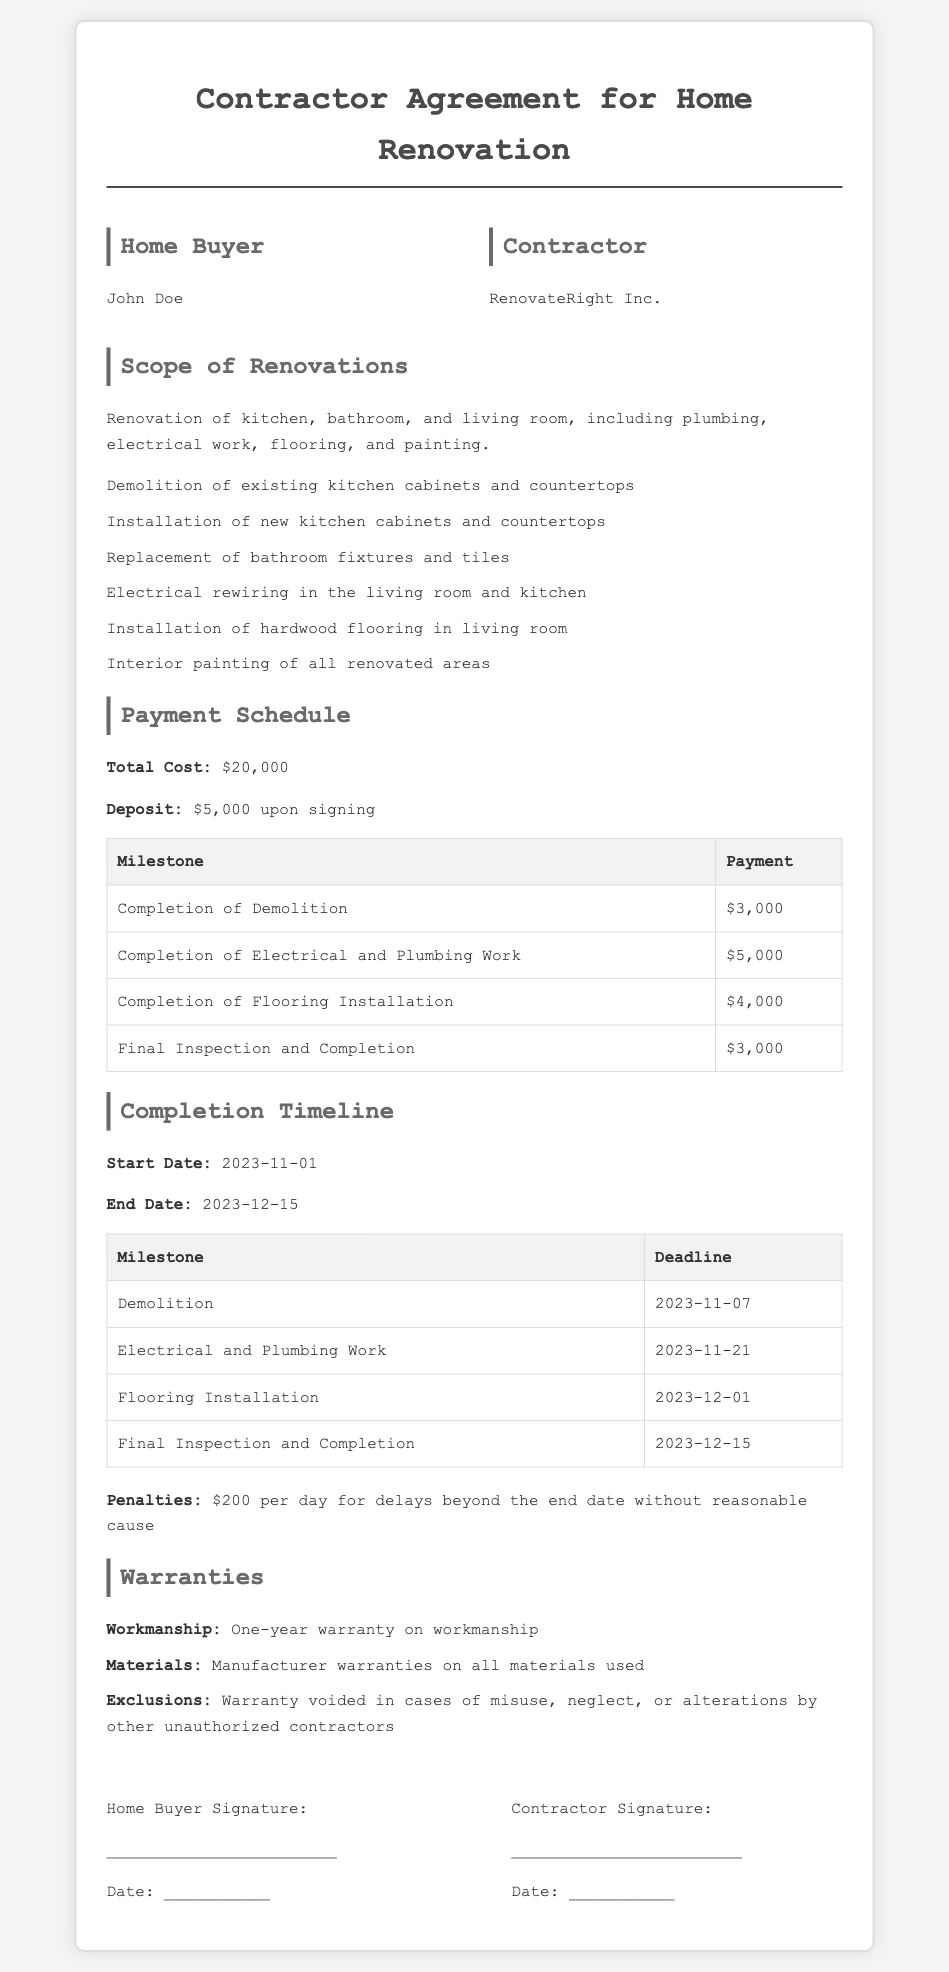what is the total cost of the renovation? The total cost is stated explicitly in the Payment Schedule section of the document.
Answer: $20,000 what is the deposit amount required upon signing? The deposit amount is specified in the Payment Schedule section.
Answer: $5,000 when is the start date of the renovation? The start date is outlined in the Completion Timeline section.
Answer: 2023-11-01 what is the penalty for delays beyond the end date? The penalty for delays is defined in the Completion Timeline section of the document.
Answer: $200 per day what is the warranty duration on workmanship? The duration of the workmanship warranty is mentioned in the Warranties section.
Answer: One-year what are the completion deadlines for electrical and plumbing work? The deadline for electrical and plumbing work is specified in the Completion Timeline section.
Answer: 2023-11-21 how many milestones are there in the payment schedule? The number of milestones is quantifiable from the Payment Schedule section.
Answer: Four what is the final payment amount due at the completion of inspection? The final payment amount is listed in the Payment Schedule section.
Answer: $3,000 what is the name of the contractor? The contractor's name appears in the Parties section of the document.
Answer: RenovateRight Inc 